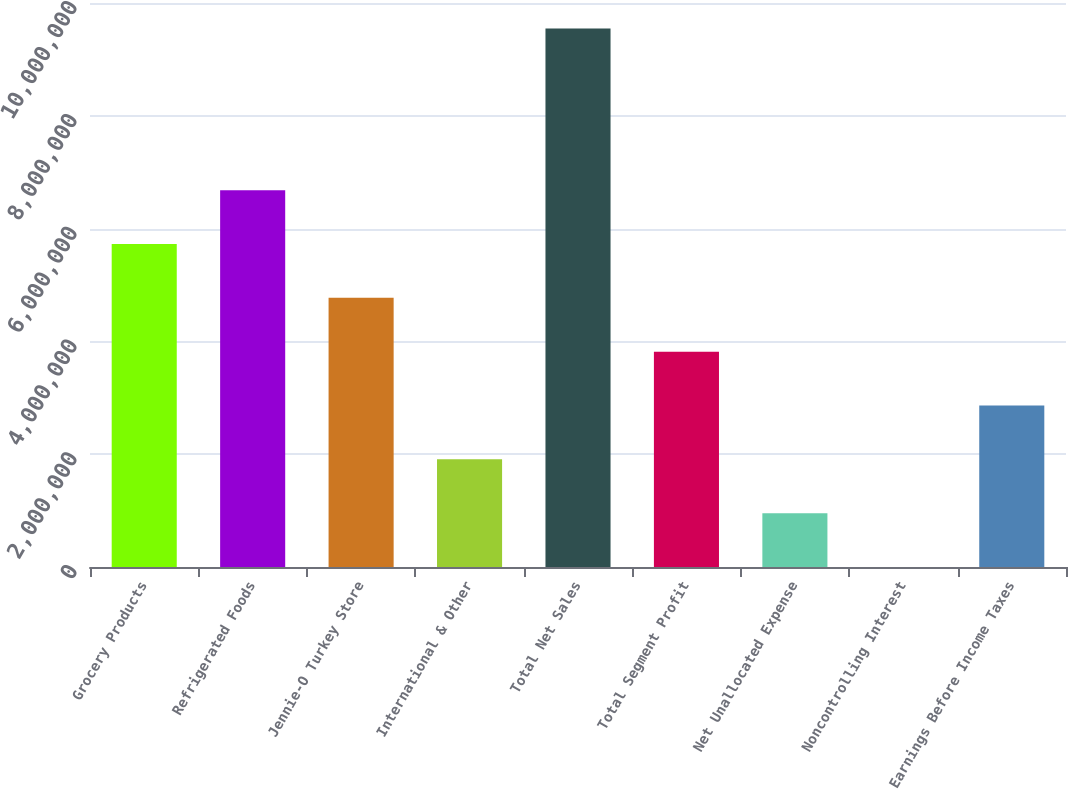Convert chart. <chart><loc_0><loc_0><loc_500><loc_500><bar_chart><fcel>Grocery Products<fcel>Refrigerated Foods<fcel>Jennie-O Turkey Store<fcel>International & Other<fcel>Total Net Sales<fcel>Total Segment Profit<fcel>Net Unallocated Expense<fcel>Noncontrolling Interest<fcel>Earnings Before Income Taxes<nl><fcel>5.7276e+06<fcel>6.68212e+06<fcel>4.77307e+06<fcel>1.90949e+06<fcel>9.5457e+06<fcel>3.81855e+06<fcel>954968<fcel>442<fcel>2.86402e+06<nl></chart> 